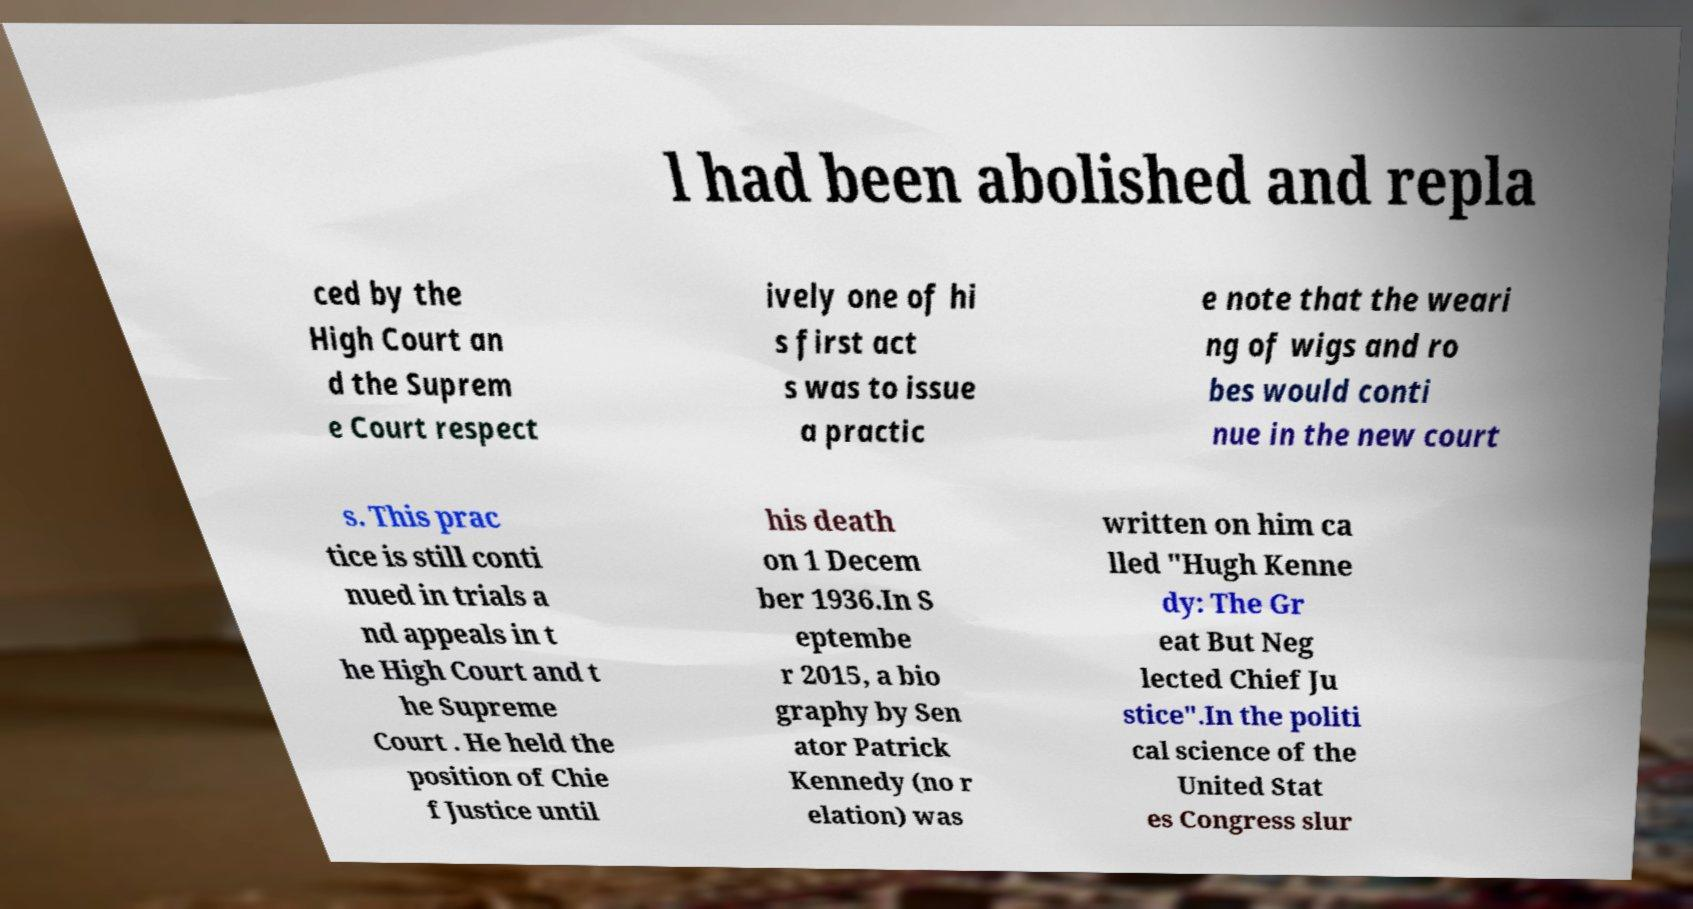Can you accurately transcribe the text from the provided image for me? l had been abolished and repla ced by the High Court an d the Suprem e Court respect ively one of hi s first act s was to issue a practic e note that the weari ng of wigs and ro bes would conti nue in the new court s. This prac tice is still conti nued in trials a nd appeals in t he High Court and t he Supreme Court . He held the position of Chie f Justice until his death on 1 Decem ber 1936.In S eptembe r 2015, a bio graphy by Sen ator Patrick Kennedy (no r elation) was written on him ca lled "Hugh Kenne dy: The Gr eat But Neg lected Chief Ju stice".In the politi cal science of the United Stat es Congress slur 